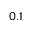Convert formula to latex. <formula><loc_0><loc_0><loc_500><loc_500>0 . 1</formula> 